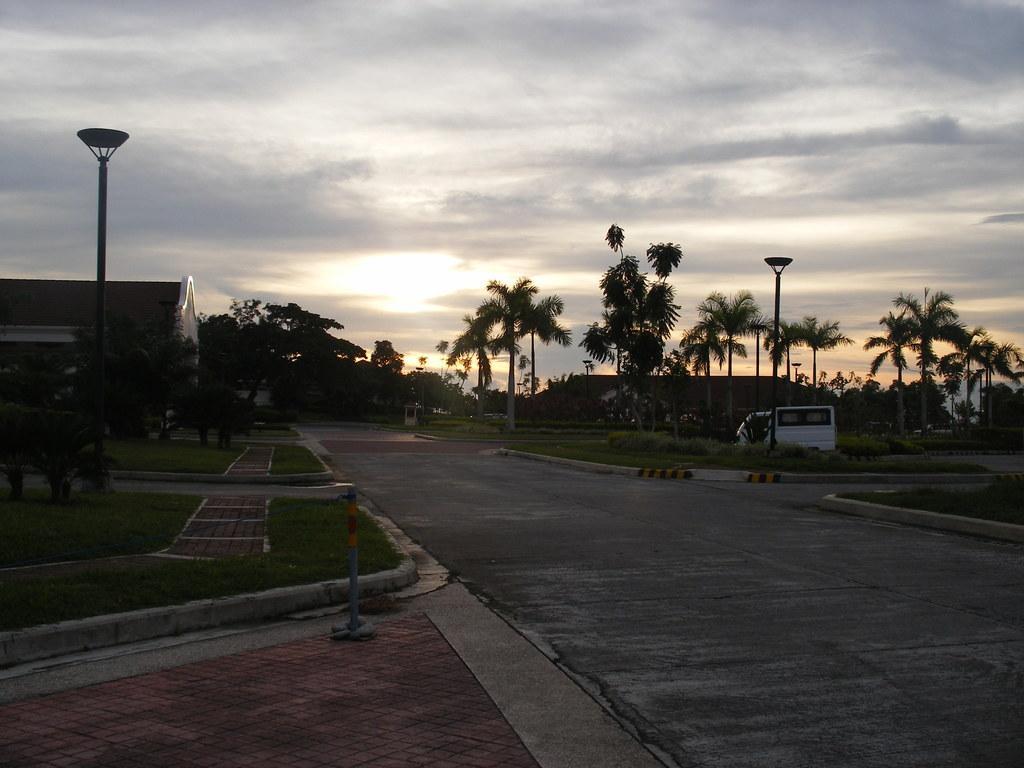Could you give a brief overview of what you see in this image? This image is clicked outside. There are trees in the middle. There is a vehicle in the middle. It is in white color. There is building on the left side. There is sky at the top. 